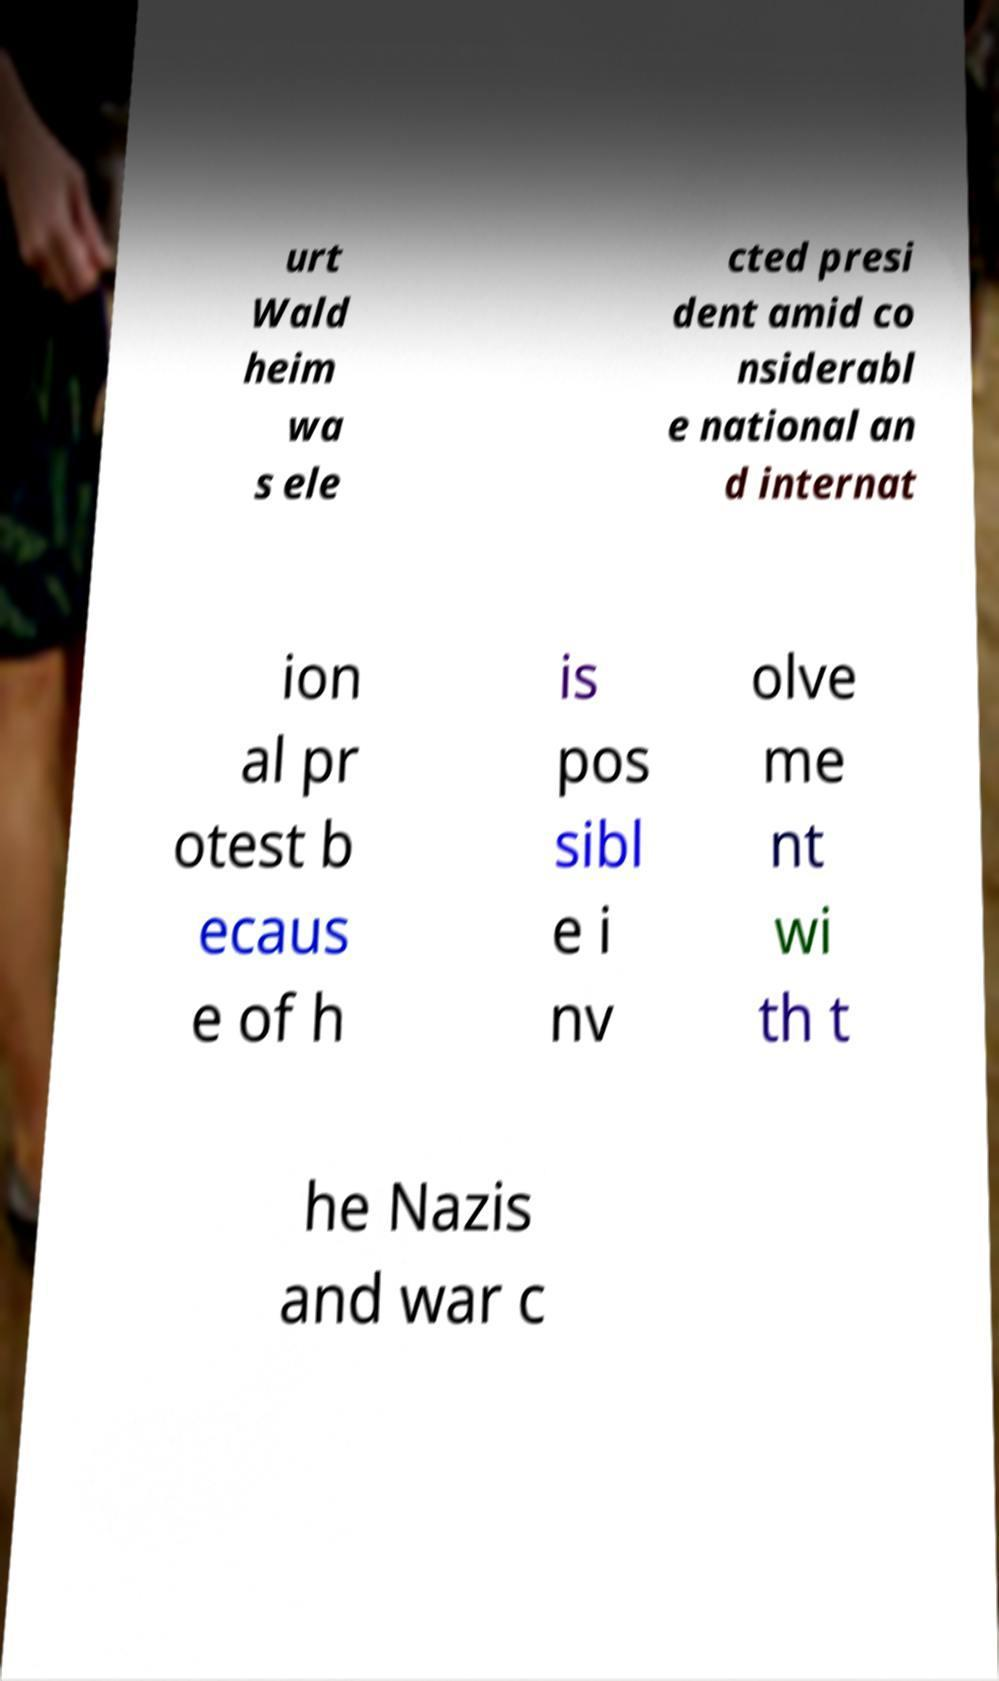What messages or text are displayed in this image? I need them in a readable, typed format. urt Wald heim wa s ele cted presi dent amid co nsiderabl e national an d internat ion al pr otest b ecaus e of h is pos sibl e i nv olve me nt wi th t he Nazis and war c 